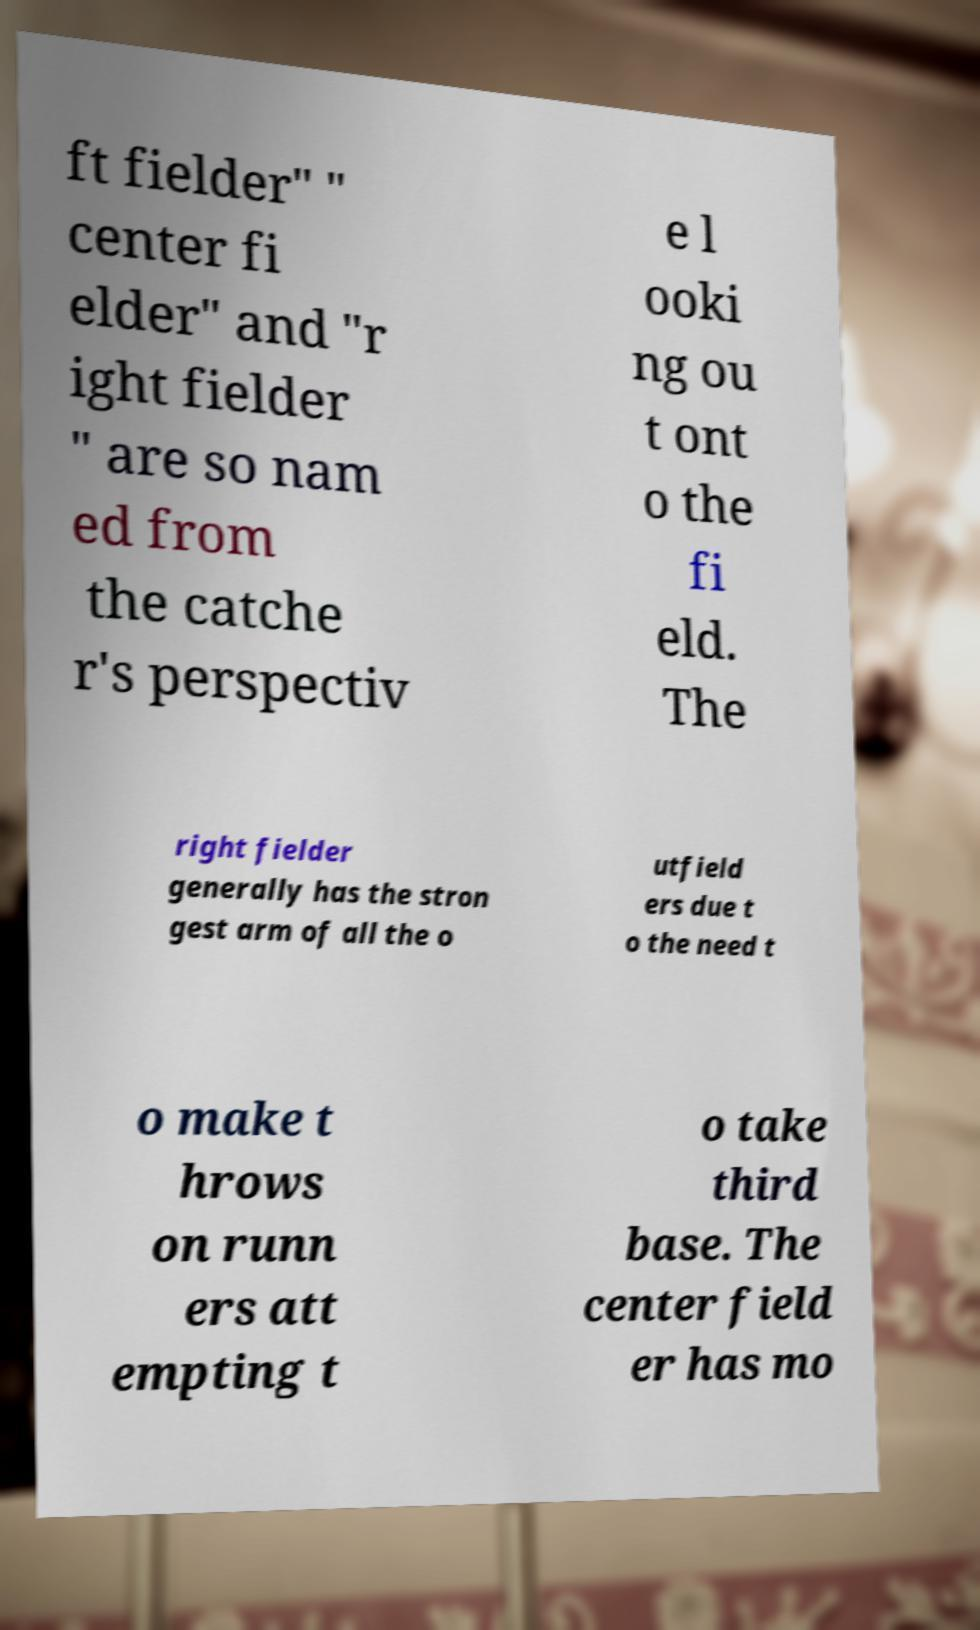Can you accurately transcribe the text from the provided image for me? ft fielder" " center fi elder" and "r ight fielder " are so nam ed from the catche r's perspectiv e l ooki ng ou t ont o the fi eld. The right fielder generally has the stron gest arm of all the o utfield ers due t o the need t o make t hrows on runn ers att empting t o take third base. The center field er has mo 